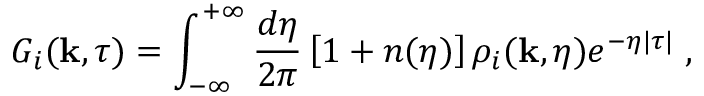Convert formula to latex. <formula><loc_0><loc_0><loc_500><loc_500>G _ { i } ( { k } , \tau ) = \int _ { - \infty } ^ { + \infty } \frac { d \eta } { 2 \pi } \left [ 1 + n ( \eta ) \right ] \rho _ { i } ( { k } , \eta ) e ^ { - \eta | \tau | } \, ,</formula> 